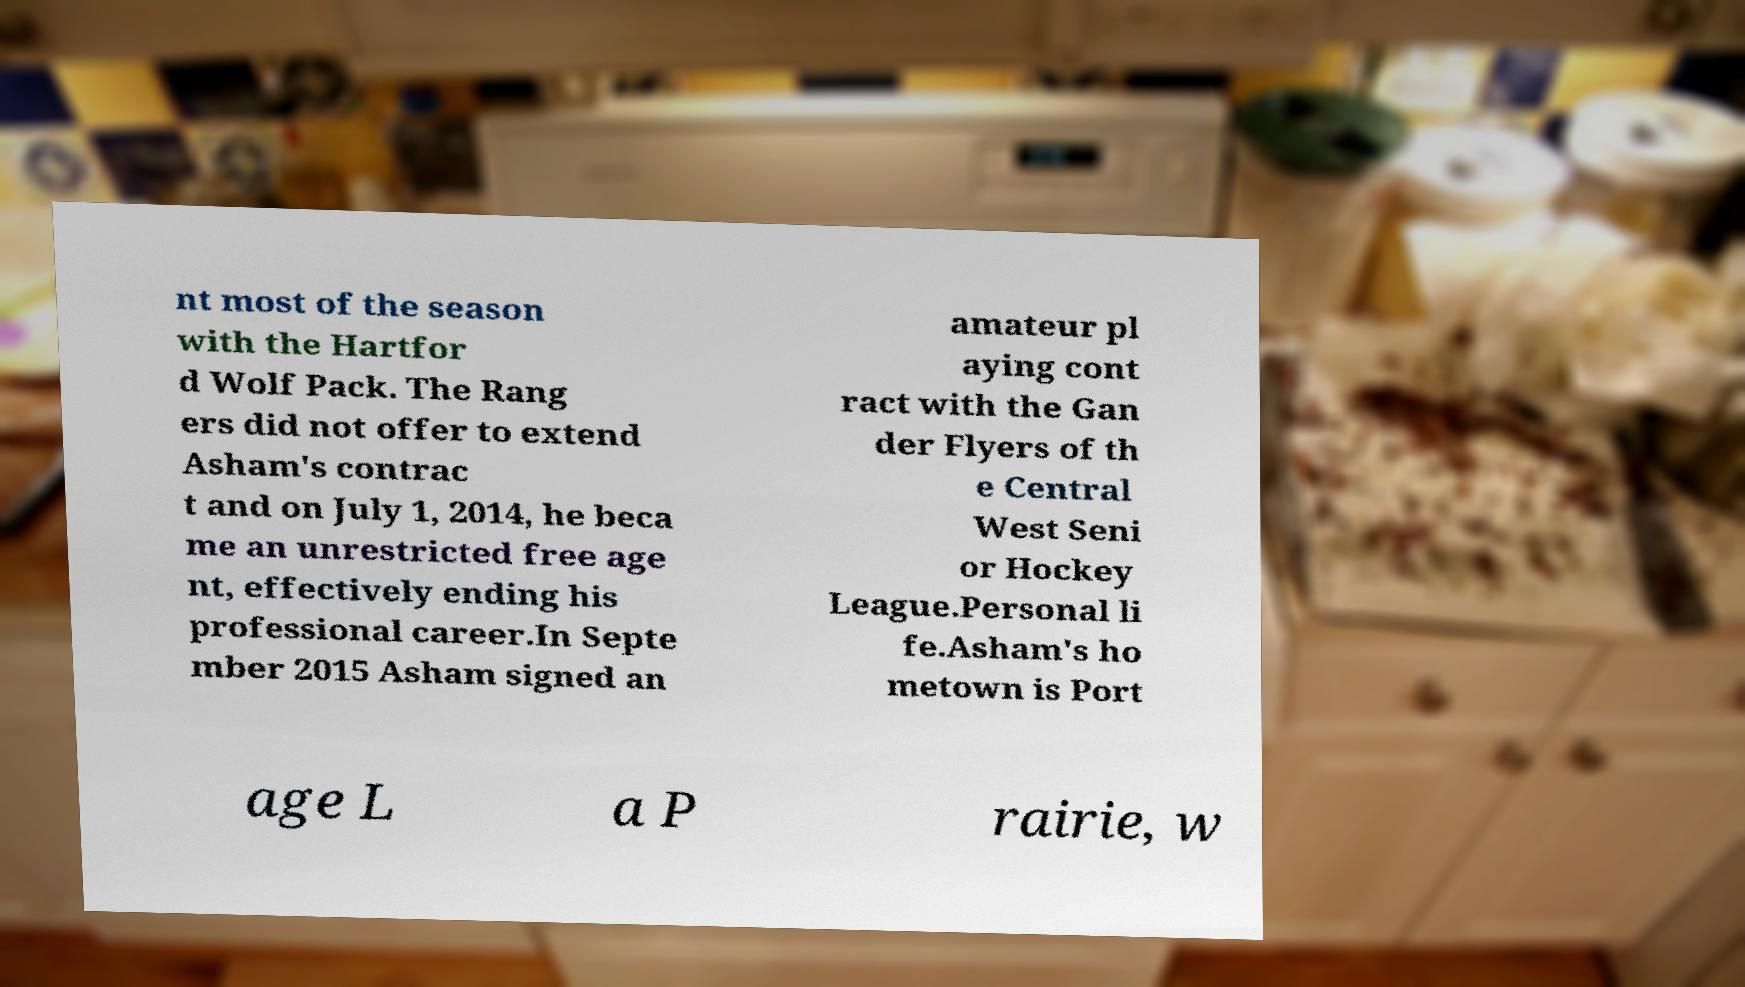What messages or text are displayed in this image? I need them in a readable, typed format. nt most of the season with the Hartfor d Wolf Pack. The Rang ers did not offer to extend Asham's contrac t and on July 1, 2014, he beca me an unrestricted free age nt, effectively ending his professional career.In Septe mber 2015 Asham signed an amateur pl aying cont ract with the Gan der Flyers of th e Central West Seni or Hockey League.Personal li fe.Asham's ho metown is Port age L a P rairie, w 